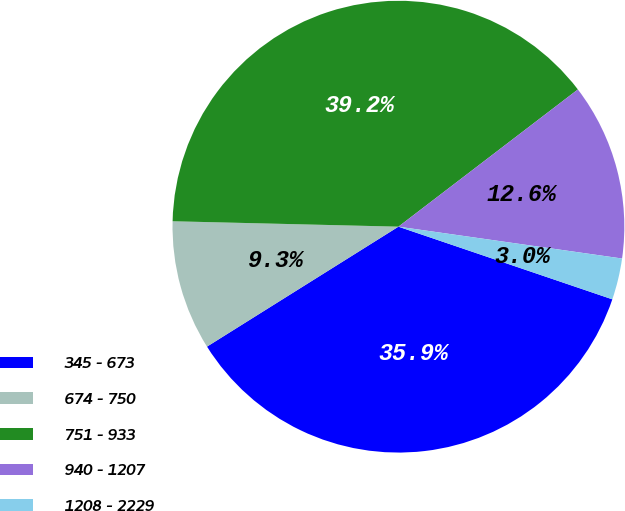Convert chart. <chart><loc_0><loc_0><loc_500><loc_500><pie_chart><fcel>345 - 673<fcel>674 - 750<fcel>751 - 933<fcel>940 - 1207<fcel>1208 - 2229<nl><fcel>35.88%<fcel>9.29%<fcel>39.23%<fcel>12.64%<fcel>2.96%<nl></chart> 